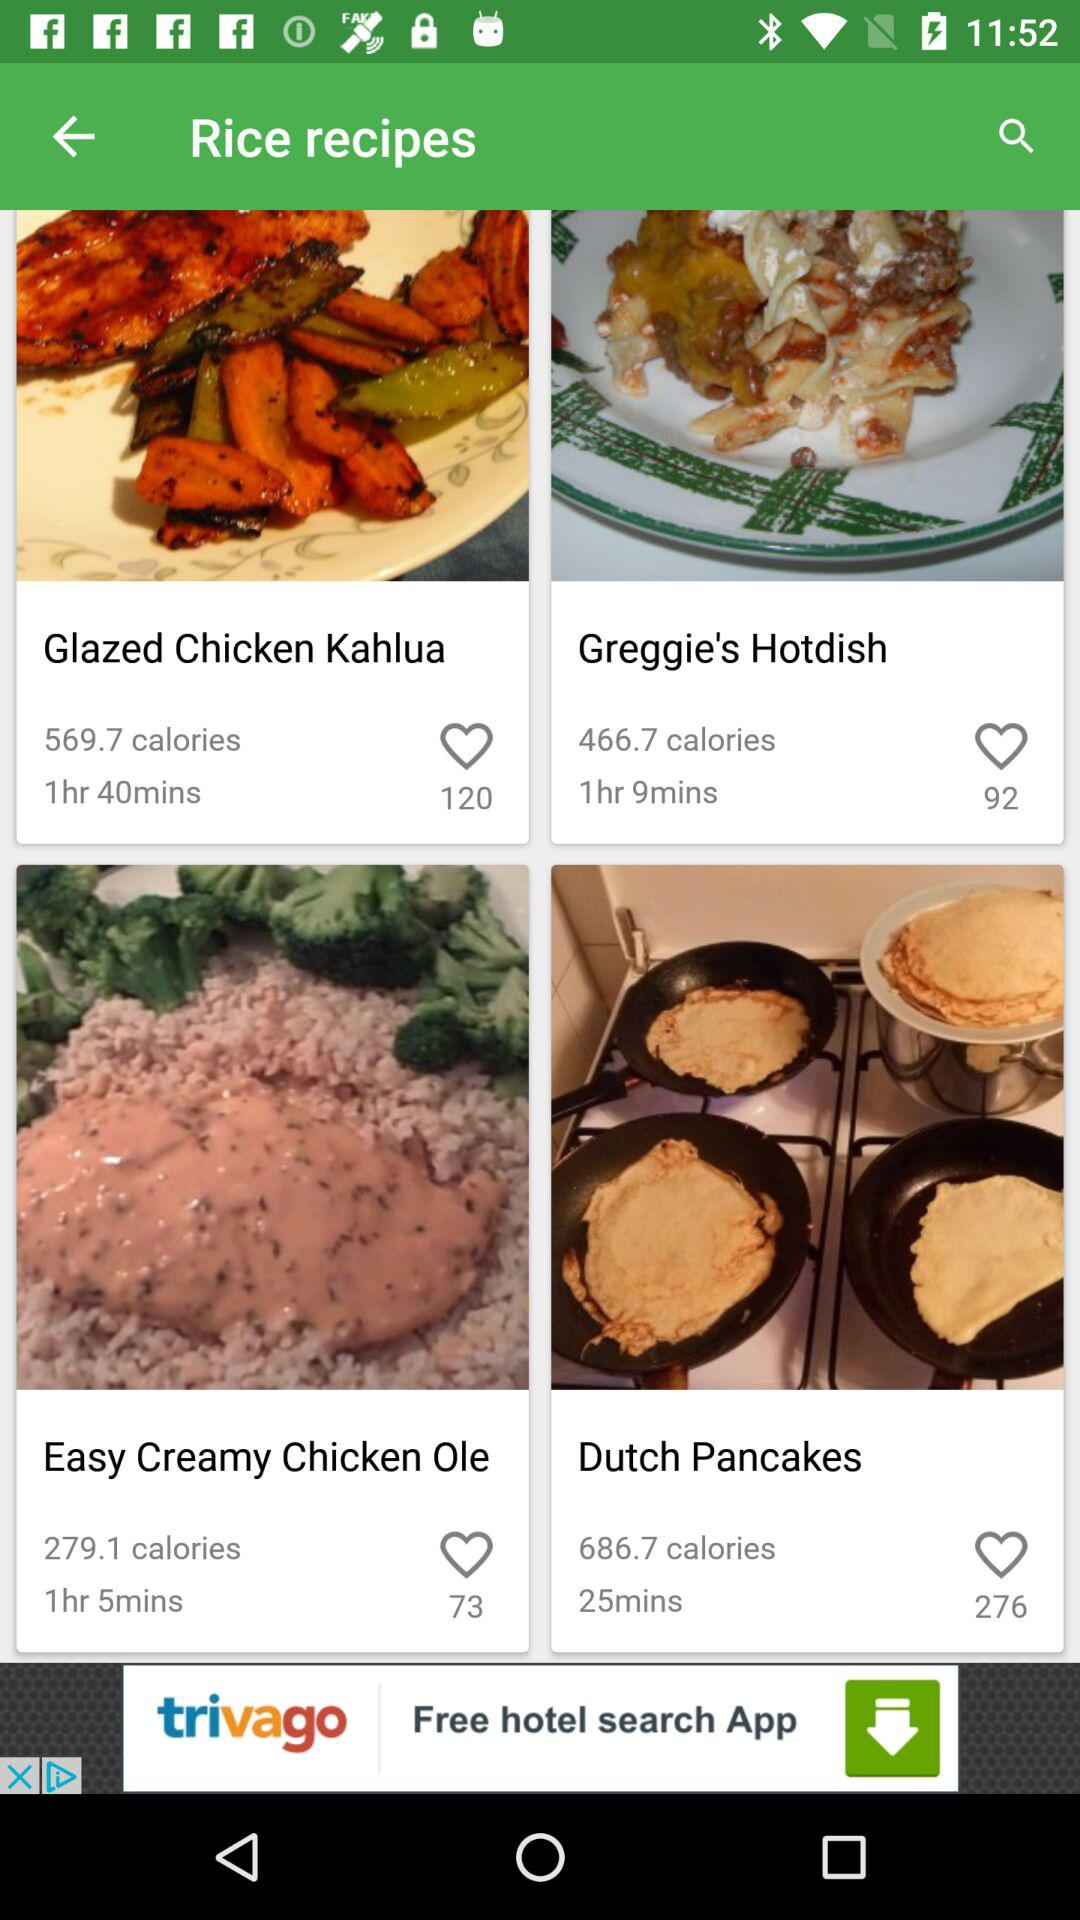How many calories are in "Glazed Chicken Kahlua"? There are 569.7 calories in "Glazed Chicken Kahlua". 